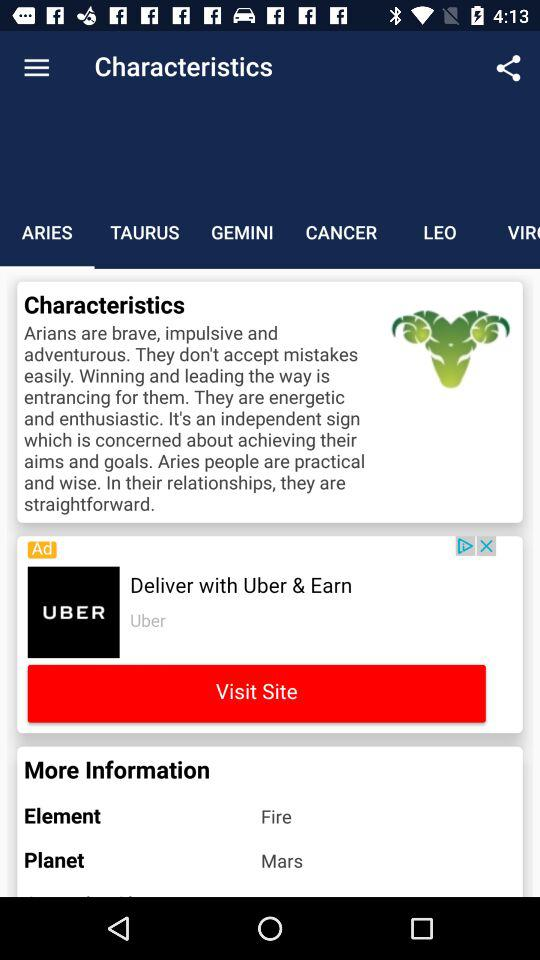What kind of people are Arians? Arians are brave, impulsive, adventurous, practical and practical. 